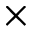<formula> <loc_0><loc_0><loc_500><loc_500>\times</formula> 